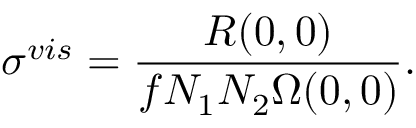<formula> <loc_0><loc_0><loc_500><loc_500>\sigma ^ { v i s } = \frac { R ( 0 , 0 ) } { f N _ { 1 } N _ { 2 } \Omega ( 0 , 0 ) } .</formula> 